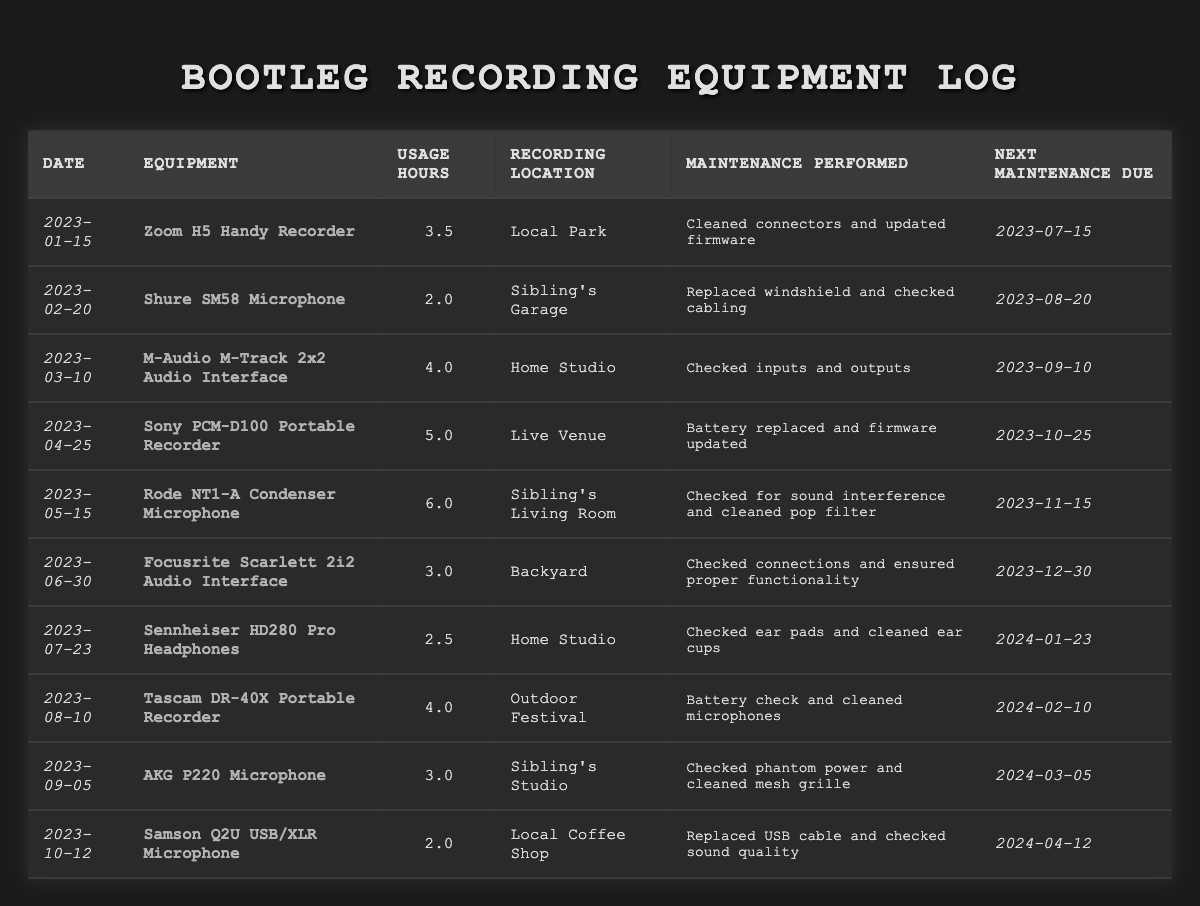What is the total usage hours recorded for the Sony PCM-D100 Portable Recorder? The entry for the Sony PCM-D100 Portable Recorder shows a usage of 5.0 hours. Thus, the total usage hours is 5.0.
Answer: 5.0 hours Which equipment had the highest usage hours logged in this table? Scanning through all entries, the Rode NT1-A Condenser Microphone shows the highest usage at 6.0 hours.
Answer: Rode NT1-A Condenser Microphone When is the next maintenance due for the Focusrite Scarlett 2i2 Audio Interface? The table lists the next maintenance due date for the Focusrite Scarlett 2i2 Audio Interface as 2023-12-30.
Answer: 2023-12-30 Did the Shure SM58 Microphone require a windshield replacement? According to the row for the Shure SM58 Microphone, maintenance performed included replacing the windshield, which confirms it did require a replacement.
Answer: Yes What is the average usage hours for the equipment recorded in January through April? The usage hours for January (3.5), February (2.0), March (4.0), and April (5.0) total to 14.5 hours. Dividing this sum by the total number of months (4), the average usage hours is 14.5/4 = 3.625.
Answer: 3.625 hours Is the next maintenance for the M-Audio M-Track 2x2 Audio Interface due later than that of the Zoom H5 Handy Recorder? The next maintenance due for the M-Audio M-Track 2x2 Audio Interface is 2023-09-10 and for the Zoom H5 Handy Recorder it is 2023-07-15. Since 2023-09-10 is after 2023-07-15, the answer is yes.
Answer: Yes How many pieces of equipment require maintenance due in 2023 after July? Looking at maintenance due dates, the following equipment have due dates after July: Rode NT1-A (November), Focusrite Scarlett (December), and two others (Tascam DR-40X in February and AKG P220 in March), which totals to 4 pieces of equipment.
Answer: 4 Which recording location was used the most for maintenance performed on equipment logged in this table? The table shows that 'Sibling's Living Room' was used for the Rode NT1-A. Observing the entries, it appears multiple locations were used but they don't repeat. Therefore, the answer is all recording locations are unique in this case.
Answer: All recording locations are unique What was the specific maintenance performed on the Samson Q2U USB/XLR Microphone? The table states that for the Samson Q2U USB/XLR Microphone, the maintenance performed was replacing the USB cable and checking sound quality, giving us that specific detail.
Answer: Replaced USB cable and checked sound quality Calculate the total number of hours used across all recorded sessions in 2023. Summing all usage hours: 3.5 + 2.0 + 4.0 + 5.0 + 6.0 + 3.0 + 2.5 + 4.0 + 3.0 + 2.0 = 31.0 hours. Thus, the total hours used across all sessions is 31.0.
Answer: 31.0 hours 